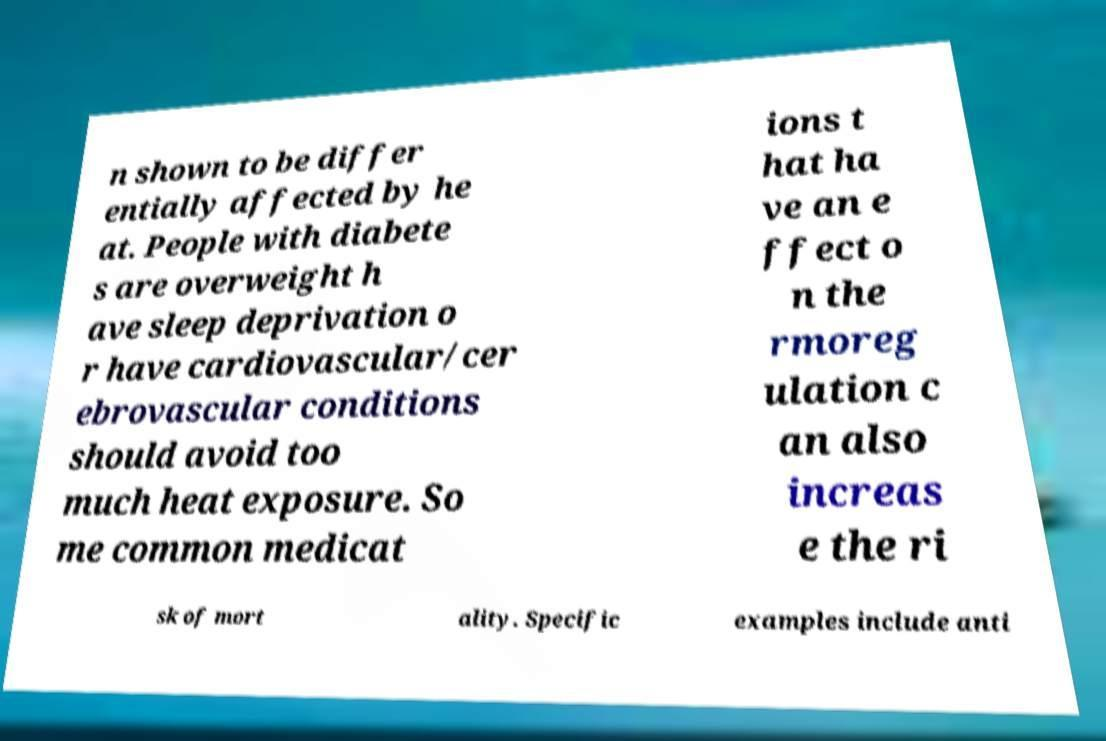Can you read and provide the text displayed in the image?This photo seems to have some interesting text. Can you extract and type it out for me? n shown to be differ entially affected by he at. People with diabete s are overweight h ave sleep deprivation o r have cardiovascular/cer ebrovascular conditions should avoid too much heat exposure. So me common medicat ions t hat ha ve an e ffect o n the rmoreg ulation c an also increas e the ri sk of mort ality. Specific examples include anti 